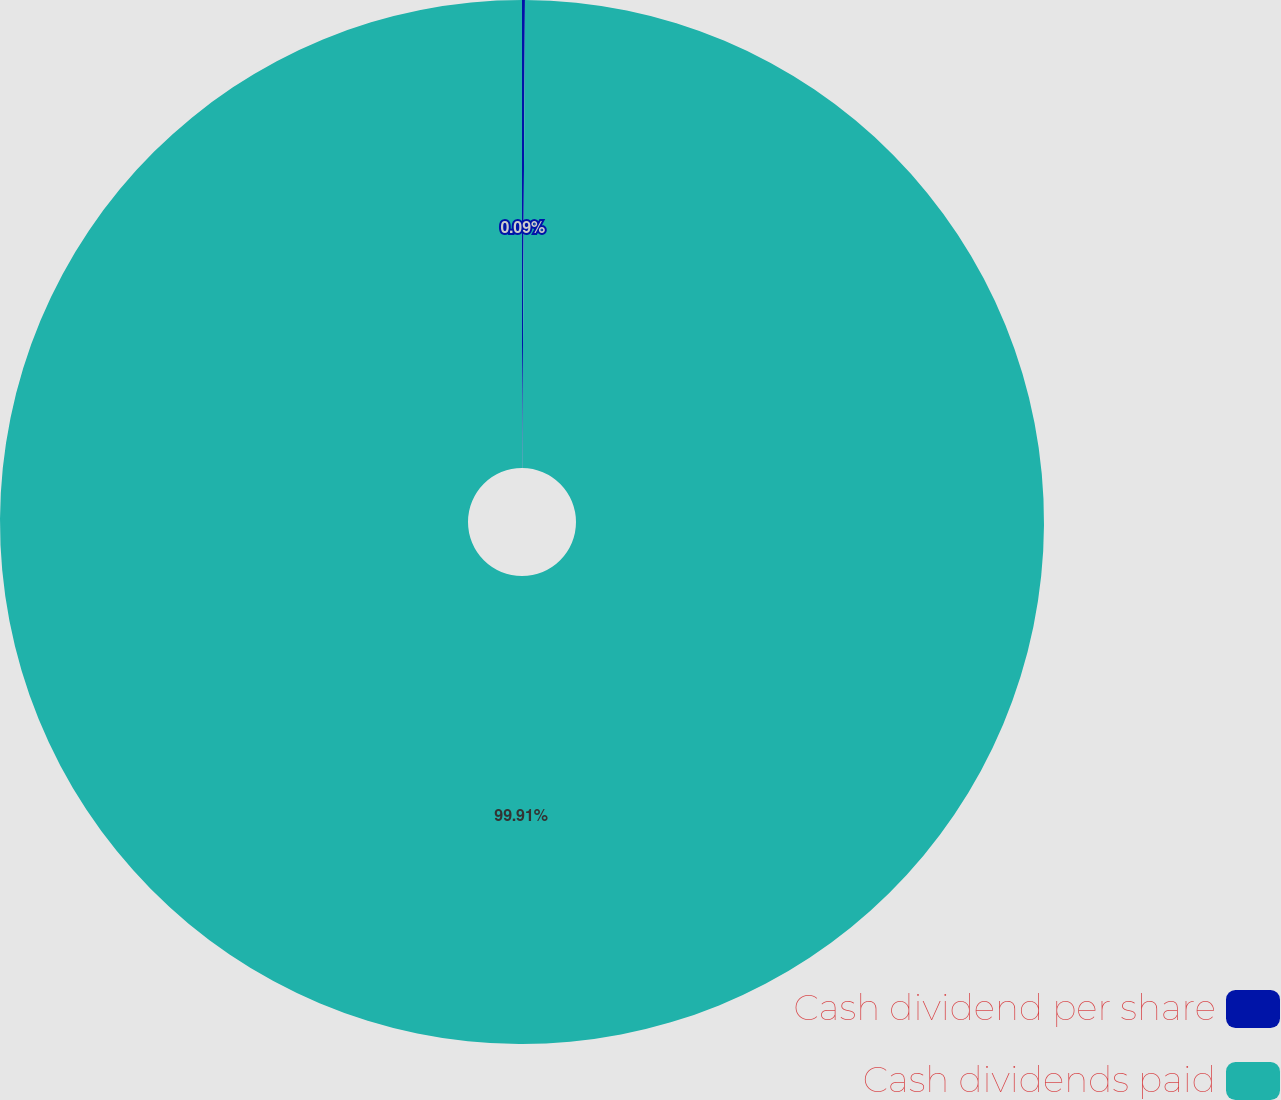Convert chart to OTSL. <chart><loc_0><loc_0><loc_500><loc_500><pie_chart><fcel>Cash dividend per share<fcel>Cash dividends paid<nl><fcel>0.09%<fcel>99.91%<nl></chart> 